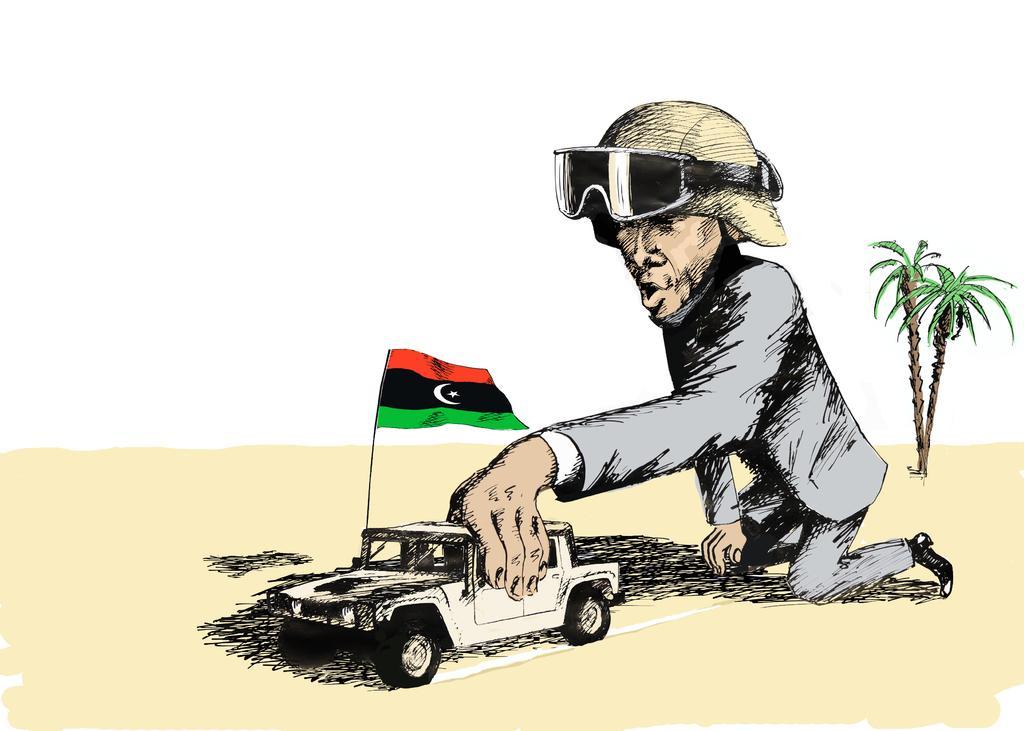Describe this image in one or two sentences. This picture contains the art of the man wearing a grey blazer is holding the white color vehicle in his hand and beside that, we see a flag which is in red, black and green color. Behind him, there are trees. In the background, it is white in color. 